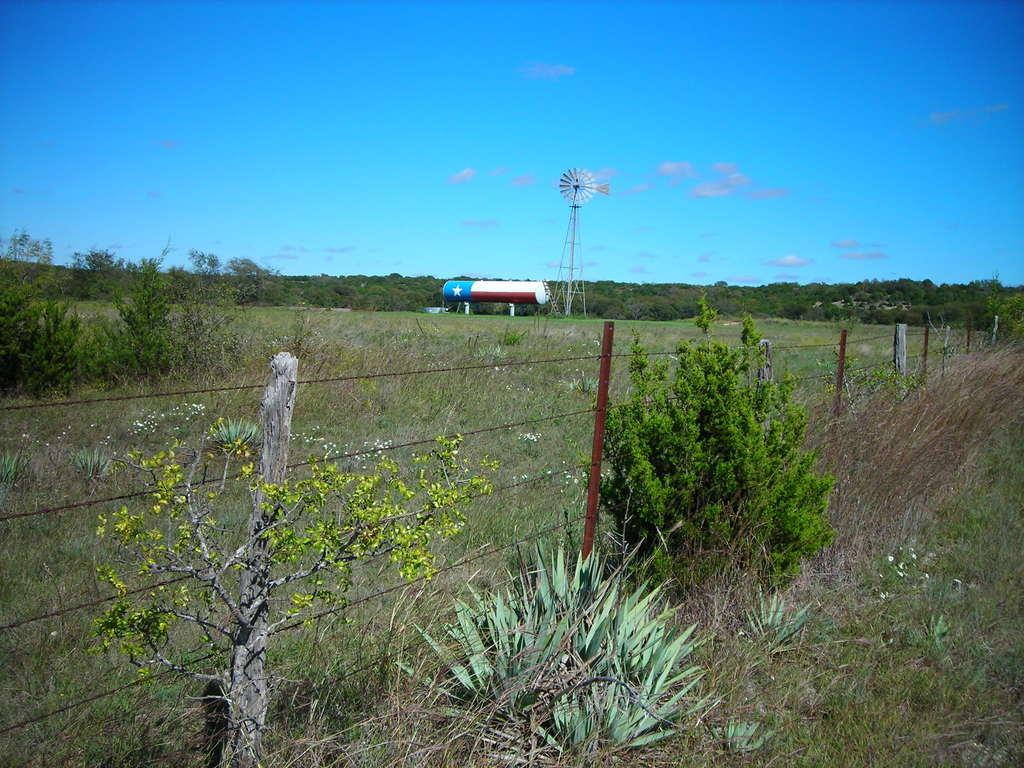What is the color of the sky in the image? The sky in the image is blue. Are there any weather phenomena visible in the sky? Yes, there are clouds in the sky. What type of natural environment surrounds the sky in the image? The sky is surrounded by plants and trees. What type of barrier can be seen in the image? There is a wired fence in the image. What type of vehicle is present in the image? There is a water tanker in the image. What type of structure can be seen in the image? There is a tower in the image. What is the chance of a pig flying in the image? There is no pig present in the image, so it is not possible to determine the chance of a pig flying. 